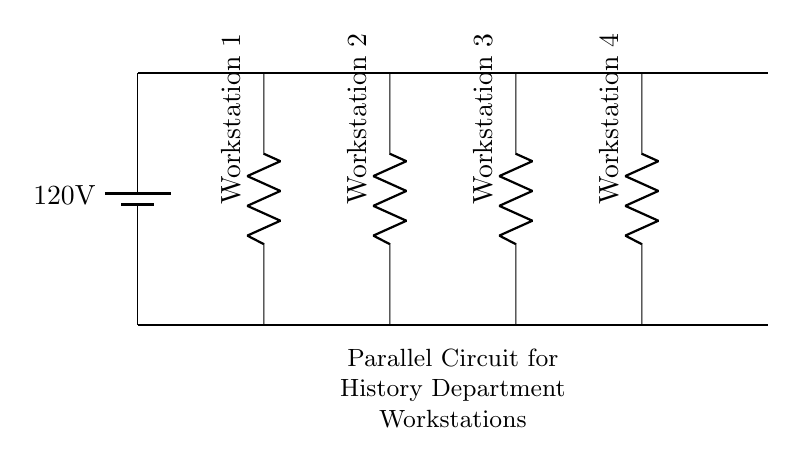What is the type of circuit shown? The circuit diagram depicts a parallel circuit because each workstation is connected across the same voltage source independently. This means that each component operates on the same voltage without being dependent on others for current supply.
Answer: Parallel circuit How many workstations are connected? There are four workstations shown in the diagram, each represented by an individual resistor connected between the voltage supply lines, confirming they are part of the same circuit configuration.
Answer: Four What is the voltage supplied to the workstations? The voltage of the circuit is 120 volts, as indicated by the battery symbol at the top of the circuit diagram. This voltage is the same supplied to all parallel components in the circuit.
Answer: 120 volts What happens if one workstation fails? If one workstation fails or is disconnected, the others will continue to function normally, as they are not dependent on each other. This characteristic is unique to parallel circuits where the failure of one path does not affect the others.
Answer: Remains operational What is the implication of having parallel workstations for power consumption? With parallel workstations, the total current drawn from the circuit increases as each workstation draws its own current based on its resistance. Therefore, the cumulative effect leads to a higher total current drawn from the power source compared to a series configuration.
Answer: Increases total current How does the current distribute among workstations? The current divides among the workstations based on their individual resistances; each workstation consumes current according to Ohm's law, and the sum of the currents through each workstation equals the total current from the supply.
Answer: Divides based on resistance 